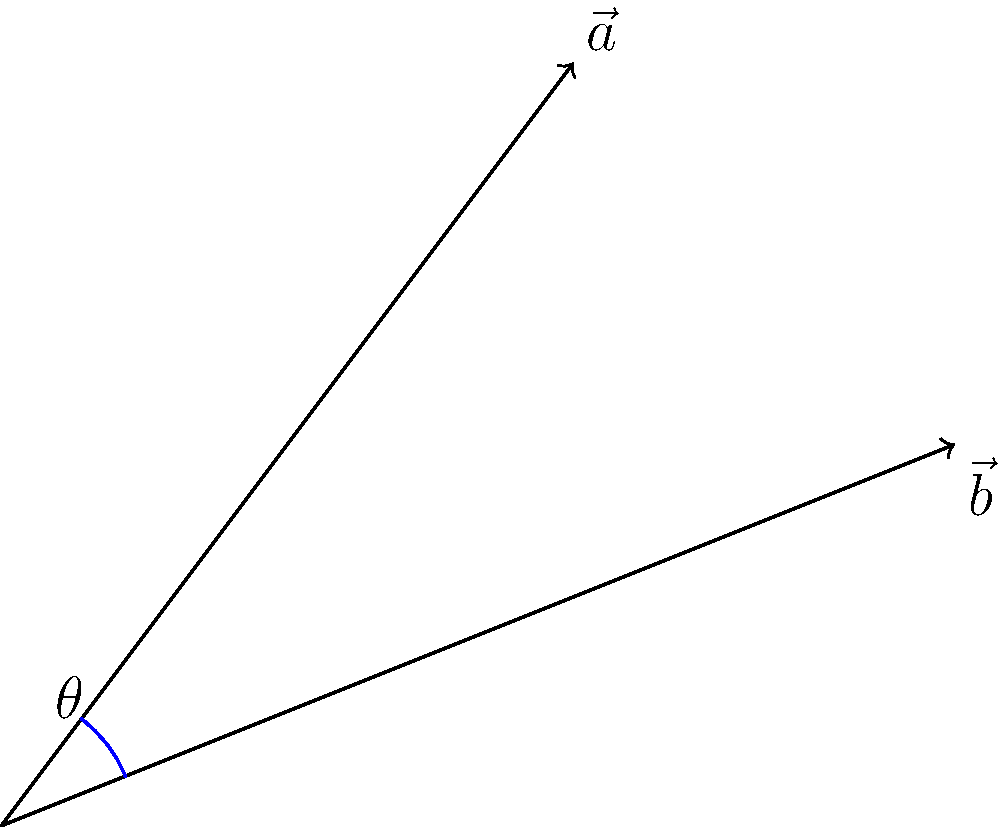In a rare flower garden, two unique species are growing at different angles. The stem of the first flower, represented by vector $\vec{a}$, grows in the direction $(3,4)$, while the stem of the second flower, represented by vector $\vec{b}$, grows in the direction $(5,2)$. What is the angle $\theta$ between these two growth directions? To find the angle between two vectors, we can use the dot product formula:

$$\cos \theta = \frac{\vec{a} \cdot \vec{b}}{|\vec{a}| |\vec{b}|}$$

Step 1: Calculate the dot product $\vec{a} \cdot \vec{b}$
$$\vec{a} \cdot \vec{b} = (3 \times 5) + (4 \times 2) = 15 + 8 = 23$$

Step 2: Calculate the magnitudes of $\vec{a}$ and $\vec{b}$
$$|\vec{a}| = \sqrt{3^2 + 4^2} = \sqrt{9 + 16} = \sqrt{25} = 5$$
$$|\vec{b}| = \sqrt{5^2 + 2^2} = \sqrt{25 + 4} = \sqrt{29}$$

Step 3: Apply the formula
$$\cos \theta = \frac{23}{5 \sqrt{29}}$$

Step 4: Take the inverse cosine (arccos) of both sides
$$\theta = \arccos(\frac{23}{5 \sqrt{29}})$$

Step 5: Calculate the result (approximately)
$$\theta \approx 0.3398 \text{ radians} \approx 19.47°$$
Answer: $19.47°$ 